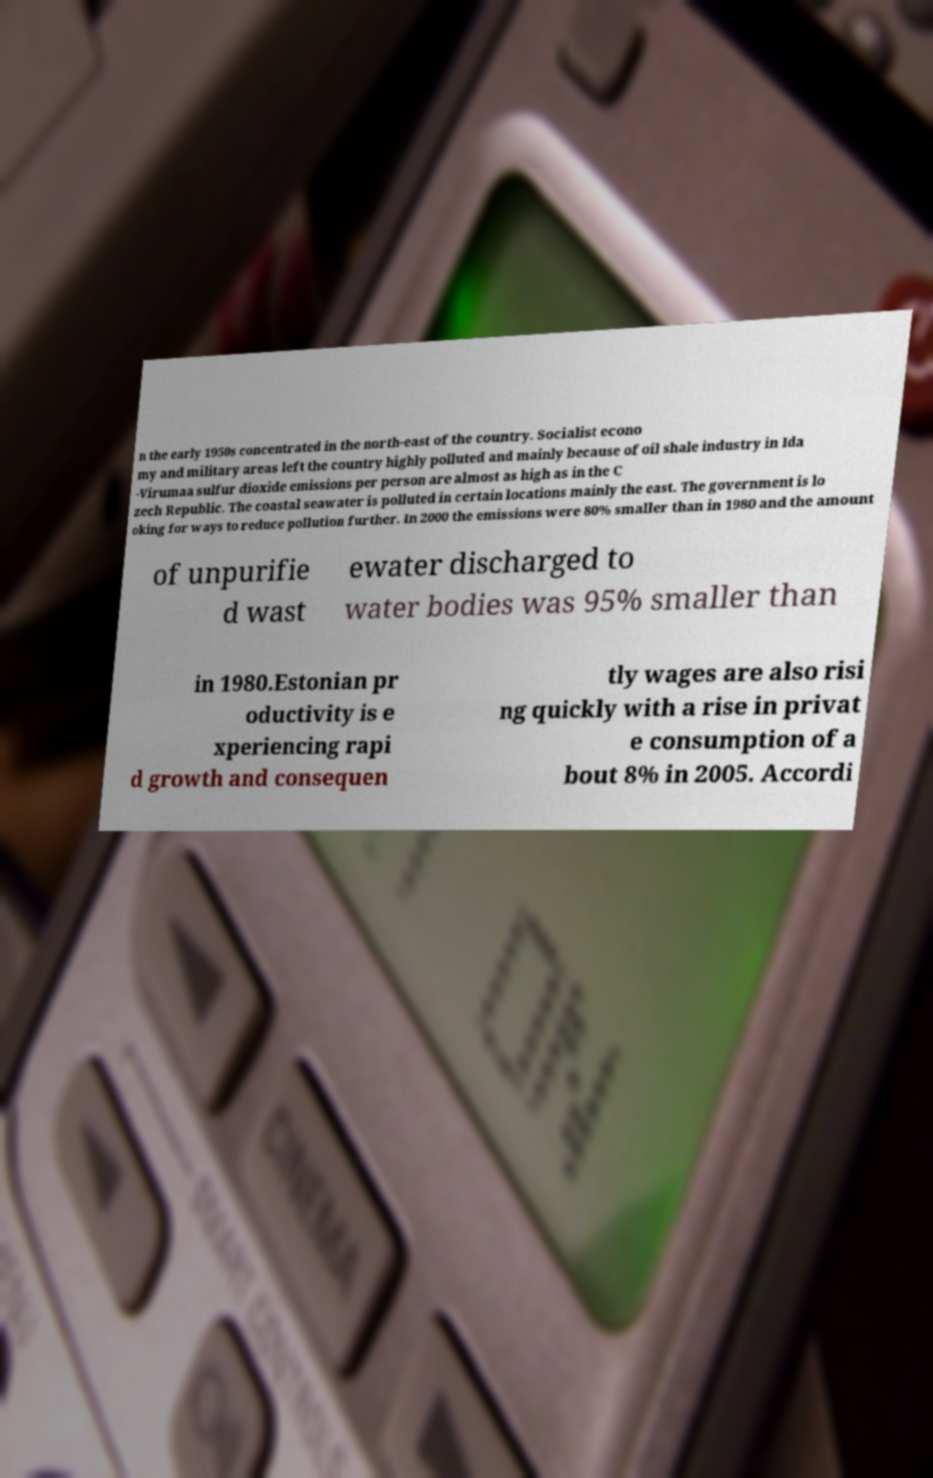What messages or text are displayed in this image? I need them in a readable, typed format. n the early 1950s concentrated in the north-east of the country. Socialist econo my and military areas left the country highly polluted and mainly because of oil shale industry in Ida -Virumaa sulfur dioxide emissions per person are almost as high as in the C zech Republic. The coastal seawater is polluted in certain locations mainly the east. The government is lo oking for ways to reduce pollution further. In 2000 the emissions were 80% smaller than in 1980 and the amount of unpurifie d wast ewater discharged to water bodies was 95% smaller than in 1980.Estonian pr oductivity is e xperiencing rapi d growth and consequen tly wages are also risi ng quickly with a rise in privat e consumption of a bout 8% in 2005. Accordi 